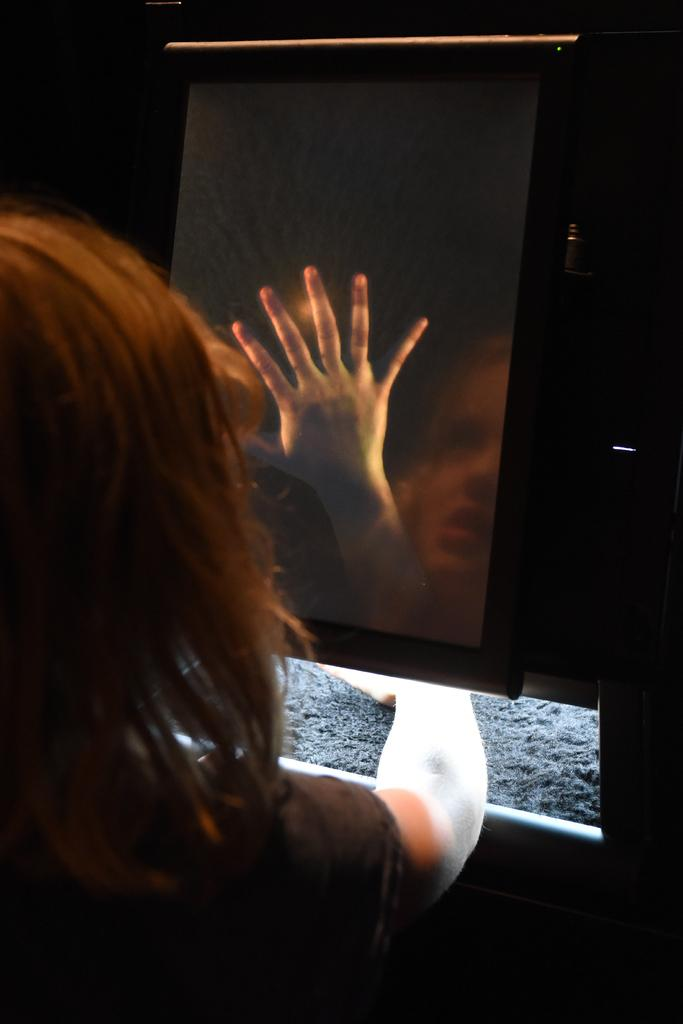Who or what is present in the image? There is a person in the image. Can you describe the person's appearance? The person is wearing clothes. What else can be seen in the image besides the person? There is a reflection of the person in the middle of the image. How many beds are visible in the image? There are no beds present in the image. Is there a rifle visible in the person's hand in the image? There is no rifle present in the image. 